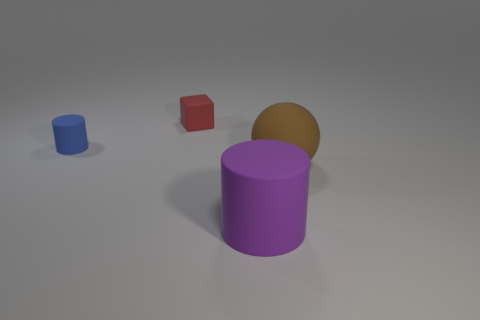Add 3 tiny yellow metallic balls. How many objects exist? 7 Subtract 1 blocks. How many blocks are left? 0 Subtract all blocks. How many objects are left? 3 Subtract all gray cylinders. How many green balls are left? 0 Subtract all blue cylinders. How many cylinders are left? 1 Subtract all gray cylinders. Subtract all gray cubes. How many cylinders are left? 2 Add 4 purple cylinders. How many purple cylinders exist? 5 Subtract 0 purple balls. How many objects are left? 4 Subtract all cyan rubber cylinders. Subtract all small cylinders. How many objects are left? 3 Add 4 large cylinders. How many large cylinders are left? 5 